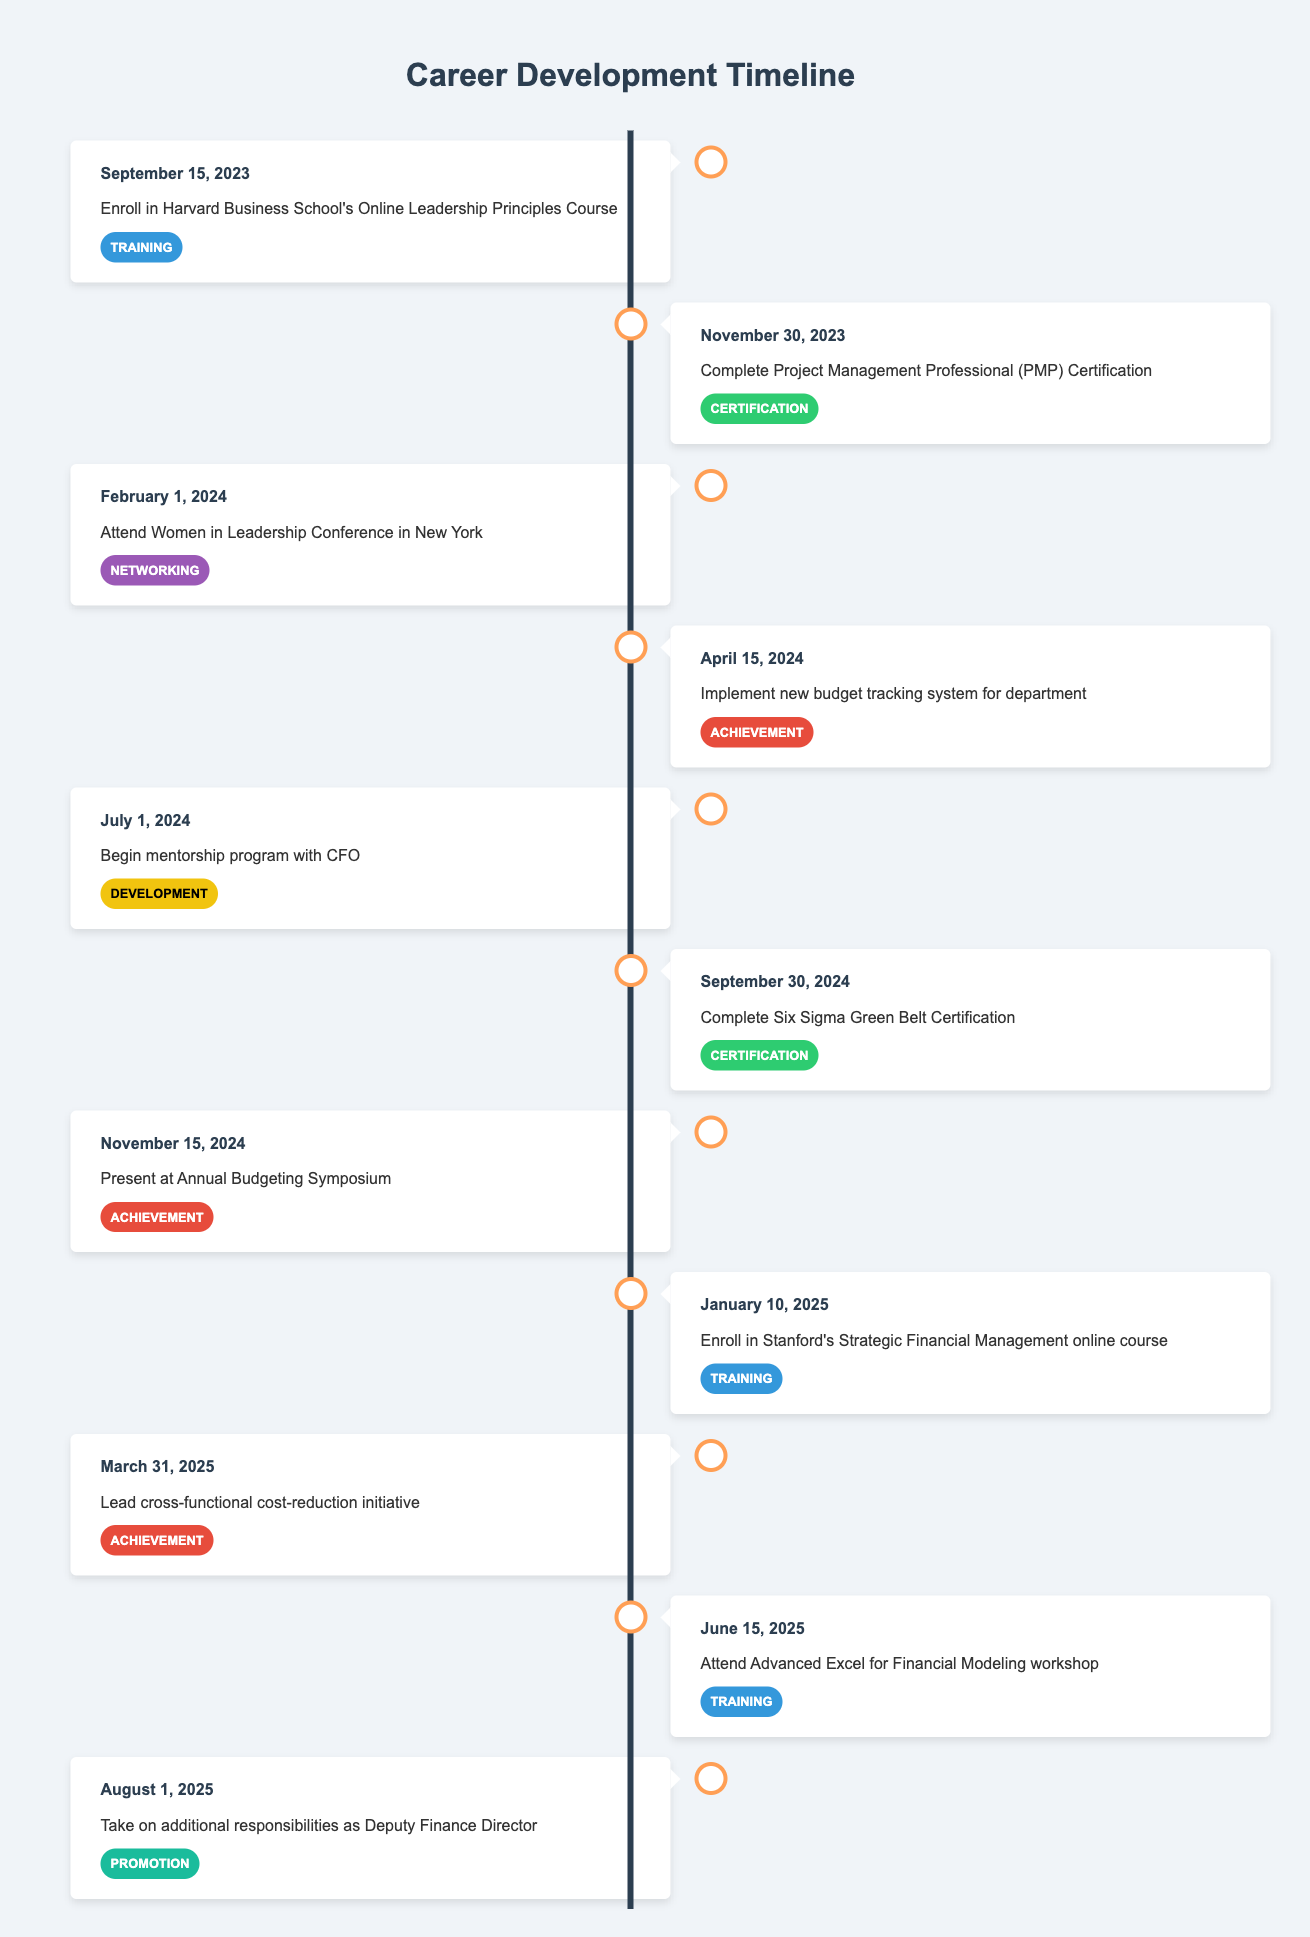What is the date for enrolling in the Leadership Principles Course? The table shows the event "Enroll in Harvard Business School's Online Leadership Principles Course" is scheduled for "September 15, 2023".
Answer: September 15, 2023 How many certifications are scheduled in the timeline? The table lists two events under the category "Certification": the Project Management Professional (PMP) Certification on November 30, 2023, and the Six Sigma Green Belt Certification on September 30, 2024. Thus, there are a total of 2 certifications.
Answer: 2 Is there an event for a mentorship program in 2024? The table shows the event "Begin mentorship program with CFO" occurring on July 1, 2024, which confirms that there is indeed a mentorship program scheduled for that year.
Answer: Yes What achievement is set for November 15, 2024? The timeline mentions the event "Present at Annual Budgeting Symposium" scheduled for November 15, 2024, which is categorized as an achievement.
Answer: Present at Annual Budgeting Symposium Which training course is planned right before taking on additional responsibilities in August 2025? The event "Attend Advanced Excel for Financial Modeling workshop" is scheduled for June 15, 2025. This is directly before the event "Take on additional responsibilities as Deputy Finance Director" which is on August 1, 2025. Therefore, the training course prior to the promotion is the Advanced Excel workshop.
Answer: Attend Advanced Excel for Financial Modeling workshop What is the total number of events listed in 2024? In 2024, there are a total of four events listed: Attend Women in Leadership Conference on February 1, Implement new budget tracking system on April 15, Complete Six Sigma Green Belt Certification on September 30, and Present at Annual Budgeting Symposium on November 15. Adding these gives us a total of 4 events in 2024.
Answer: 4 Was there any event categorized as "Promotion" before August 2025? Reviewing the timeline, there are no entries categorized as "Promotion" before August 2025; the only event in this category happens on August 1, 2025. Therefore, the answer is no, as there are no prior promotions recorded.
Answer: No Which category does the event on April 15, 2024, belong to? The table indicates the event on April 15, 2024, is "Implement new budget tracking system for department", which is categorized as an "Achievement".
Answer: Achievement How many months are there between the completion of the PMP Certification and the Six Sigma Green Belt Certification? The completion date for PMP Certification is November 30, 2023, and for SSGB Certification is September 30, 2024. Counting the full months, December 2023 to September 2024 gives us 10 months in total.
Answer: 10 months 